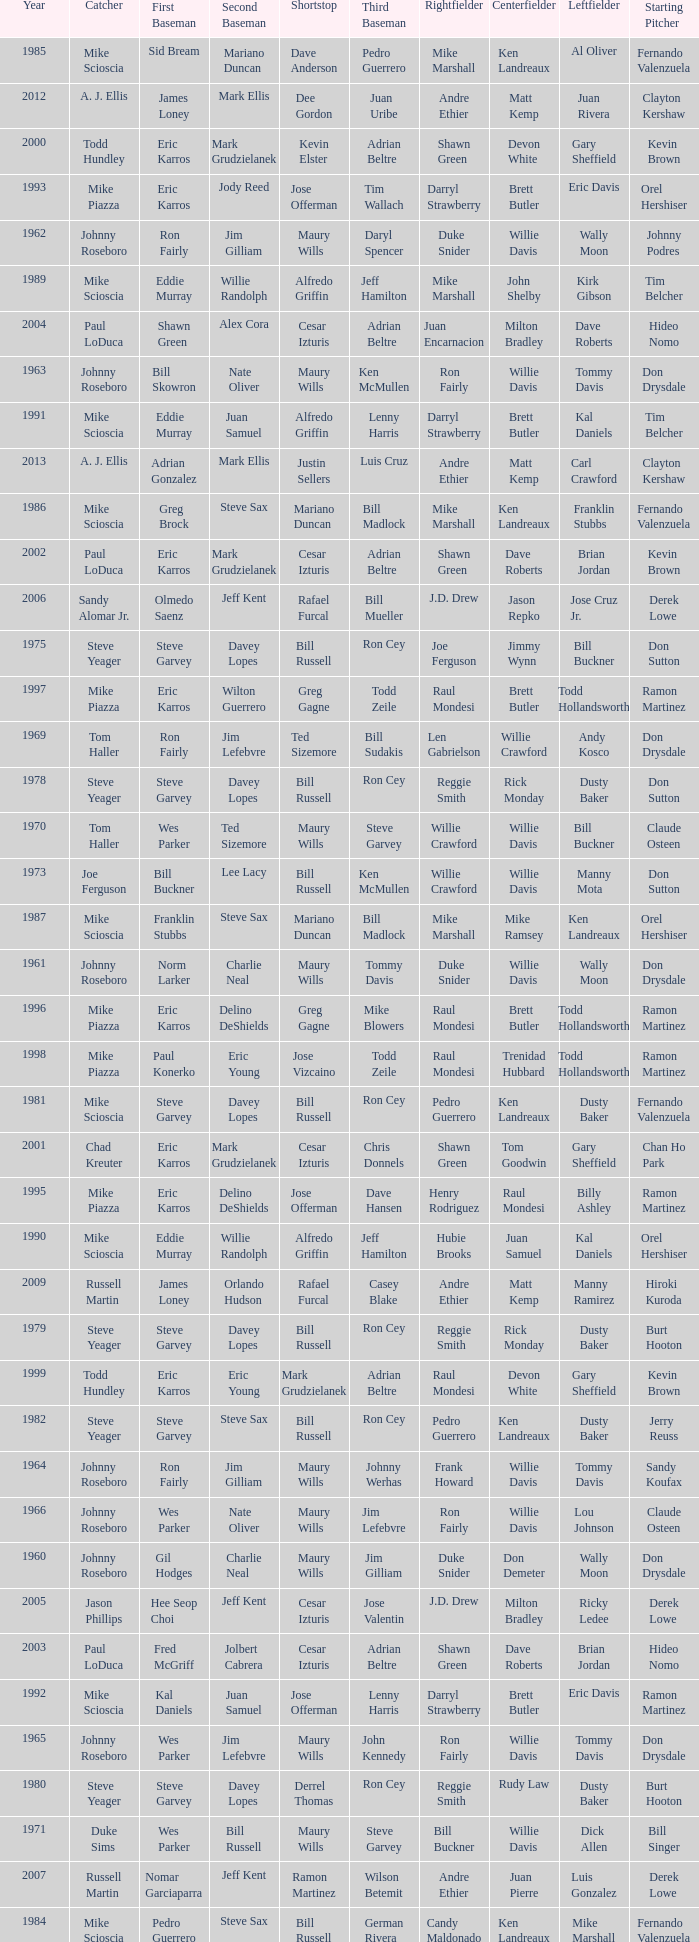Who played 2nd base when nomar garciaparra was at 1st base? Jeff Kent. 